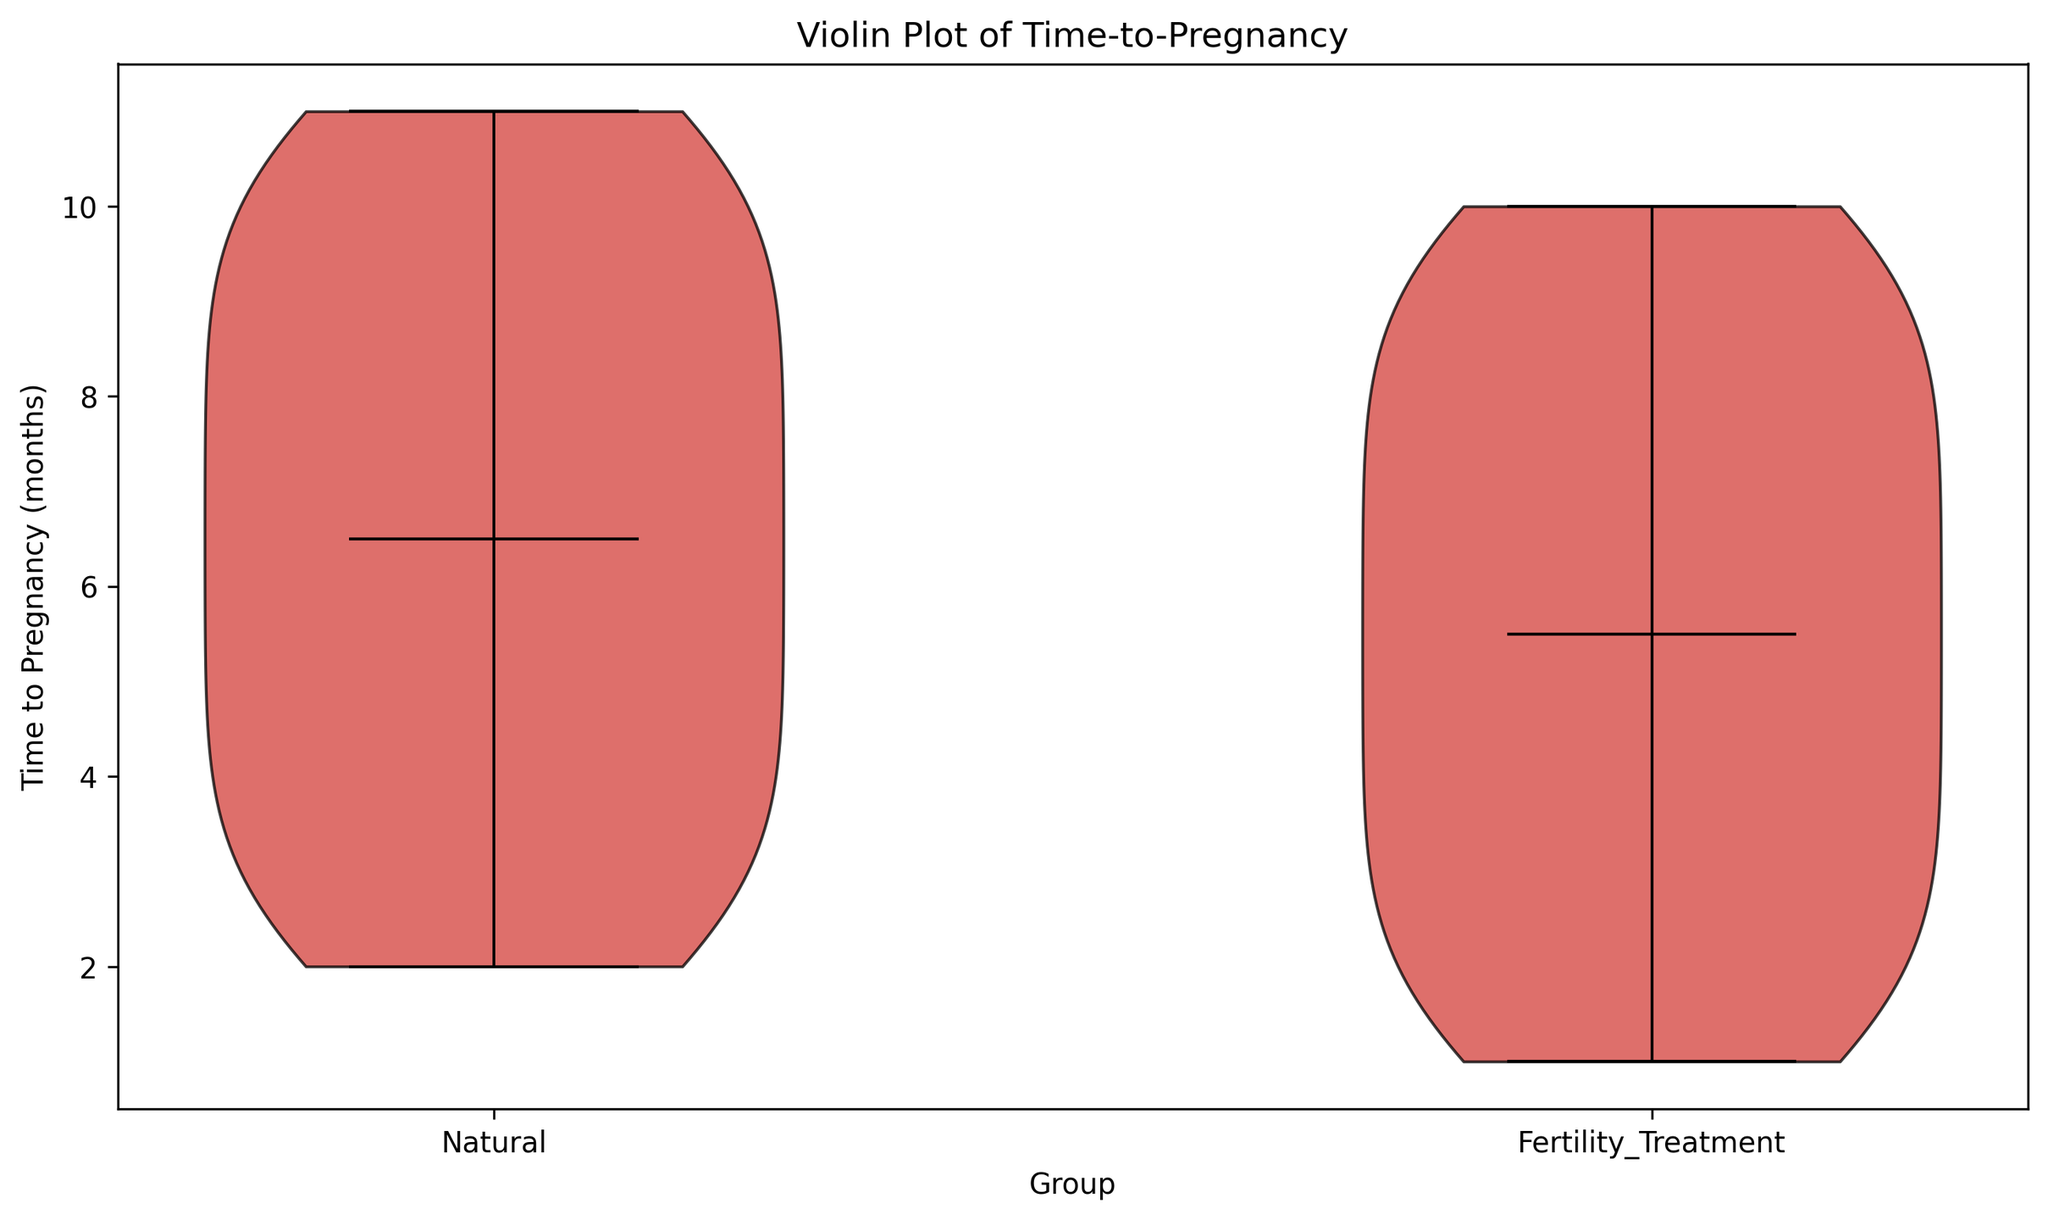Which group has a lower median time-to-pregnancy? By observing the violin plot, the median is represented by the horizontal line inside each violin. The median for the Fertility_Treatment group is lower than that of the Natural group.
Answer: Fertility_Treatment What is the range of time-to-pregnancy for women using fertility treatments? The range is determined by the minimum and maximum values shown in the violins. For the Fertility_Treatment group, this range spans from 1 month (base of the violin) to 10 months (top of the violin).
Answer: 1 to 10 months Which group shows a wider distribution of time-to-pregnancy? A wider distribution implies a broader spread in the values. The Natural group's violin plot visually appears wider, indicating greater variability.
Answer: Natural Are the means of time-to-pregnancy the same for both groups? The means are shown within the violins as dots. By comparing these visually, it appears that the means are close but not exactly the same.
Answer: No Which group has the lower mean time-to-pregnancy? The Fertility_Treatment group shows a lower mean, indicated by the position of the dot within the lower section of the violin compared to the Natural group.
Answer: Fertility_Treatment Is the peak of the Natural group's distribution higher or lower compared to the Fertility_Treatment group? The peak, or mode, of the violin plot for the Natural group appears higher, indicating a concentration of values in a higher range of months.
Answer: Higher Does either group show any outliers in their distribution? Outliers would appear as individual points outside the main body of the violin plot. Observing both violins, neither group shows distinct outliers outside the main distribution.
Answer: No What are the median and mean values for the Natural group? To find these values, look for the horizontal line (median) and the dot (mean) within the Natural group's violin. The median is around 6-7 months, and the mean is around 6.5 months.
Answer: Median: ~6-7 months, Mean: ~6.5 months Is there more variability in time-to-pregnancy for women using fertility treatments or for those conceiving naturally? Variability is represented by the spread of the violin plot. The Natural group shows a wider spread indicating higher variability compared to the Fertility_Treatment group.
Answer: Natural 